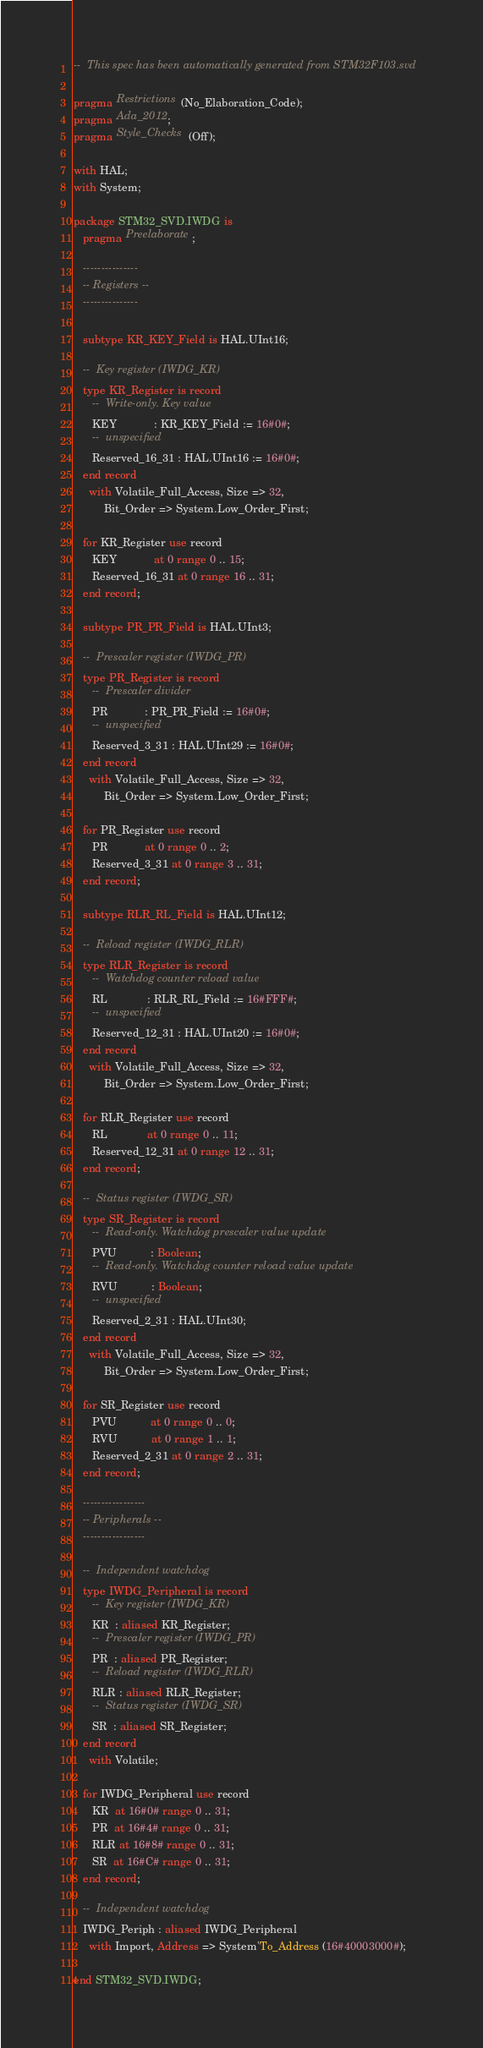Convert code to text. <code><loc_0><loc_0><loc_500><loc_500><_Ada_>--  This spec has been automatically generated from STM32F103.svd

pragma Restrictions (No_Elaboration_Code);
pragma Ada_2012;
pragma Style_Checks (Off);

with HAL;
with System;

package STM32_SVD.IWDG is
   pragma Preelaborate;

   ---------------
   -- Registers --
   ---------------

   subtype KR_KEY_Field is HAL.UInt16;

   --  Key register (IWDG_KR)
   type KR_Register is record
      --  Write-only. Key value
      KEY            : KR_KEY_Field := 16#0#;
      --  unspecified
      Reserved_16_31 : HAL.UInt16 := 16#0#;
   end record
     with Volatile_Full_Access, Size => 32,
          Bit_Order => System.Low_Order_First;

   for KR_Register use record
      KEY            at 0 range 0 .. 15;
      Reserved_16_31 at 0 range 16 .. 31;
   end record;

   subtype PR_PR_Field is HAL.UInt3;

   --  Prescaler register (IWDG_PR)
   type PR_Register is record
      --  Prescaler divider
      PR            : PR_PR_Field := 16#0#;
      --  unspecified
      Reserved_3_31 : HAL.UInt29 := 16#0#;
   end record
     with Volatile_Full_Access, Size => 32,
          Bit_Order => System.Low_Order_First;

   for PR_Register use record
      PR            at 0 range 0 .. 2;
      Reserved_3_31 at 0 range 3 .. 31;
   end record;

   subtype RLR_RL_Field is HAL.UInt12;

   --  Reload register (IWDG_RLR)
   type RLR_Register is record
      --  Watchdog counter reload value
      RL             : RLR_RL_Field := 16#FFF#;
      --  unspecified
      Reserved_12_31 : HAL.UInt20 := 16#0#;
   end record
     with Volatile_Full_Access, Size => 32,
          Bit_Order => System.Low_Order_First;

   for RLR_Register use record
      RL             at 0 range 0 .. 11;
      Reserved_12_31 at 0 range 12 .. 31;
   end record;

   --  Status register (IWDG_SR)
   type SR_Register is record
      --  Read-only. Watchdog prescaler value update
      PVU           : Boolean;
      --  Read-only. Watchdog counter reload value update
      RVU           : Boolean;
      --  unspecified
      Reserved_2_31 : HAL.UInt30;
   end record
     with Volatile_Full_Access, Size => 32,
          Bit_Order => System.Low_Order_First;

   for SR_Register use record
      PVU           at 0 range 0 .. 0;
      RVU           at 0 range 1 .. 1;
      Reserved_2_31 at 0 range 2 .. 31;
   end record;

   -----------------
   -- Peripherals --
   -----------------

   --  Independent watchdog
   type IWDG_Peripheral is record
      --  Key register (IWDG_KR)
      KR  : aliased KR_Register;
      --  Prescaler register (IWDG_PR)
      PR  : aliased PR_Register;
      --  Reload register (IWDG_RLR)
      RLR : aliased RLR_Register;
      --  Status register (IWDG_SR)
      SR  : aliased SR_Register;
   end record
     with Volatile;

   for IWDG_Peripheral use record
      KR  at 16#0# range 0 .. 31;
      PR  at 16#4# range 0 .. 31;
      RLR at 16#8# range 0 .. 31;
      SR  at 16#C# range 0 .. 31;
   end record;

   --  Independent watchdog
   IWDG_Periph : aliased IWDG_Peripheral
     with Import, Address => System'To_Address (16#40003000#);

end STM32_SVD.IWDG;
</code> 